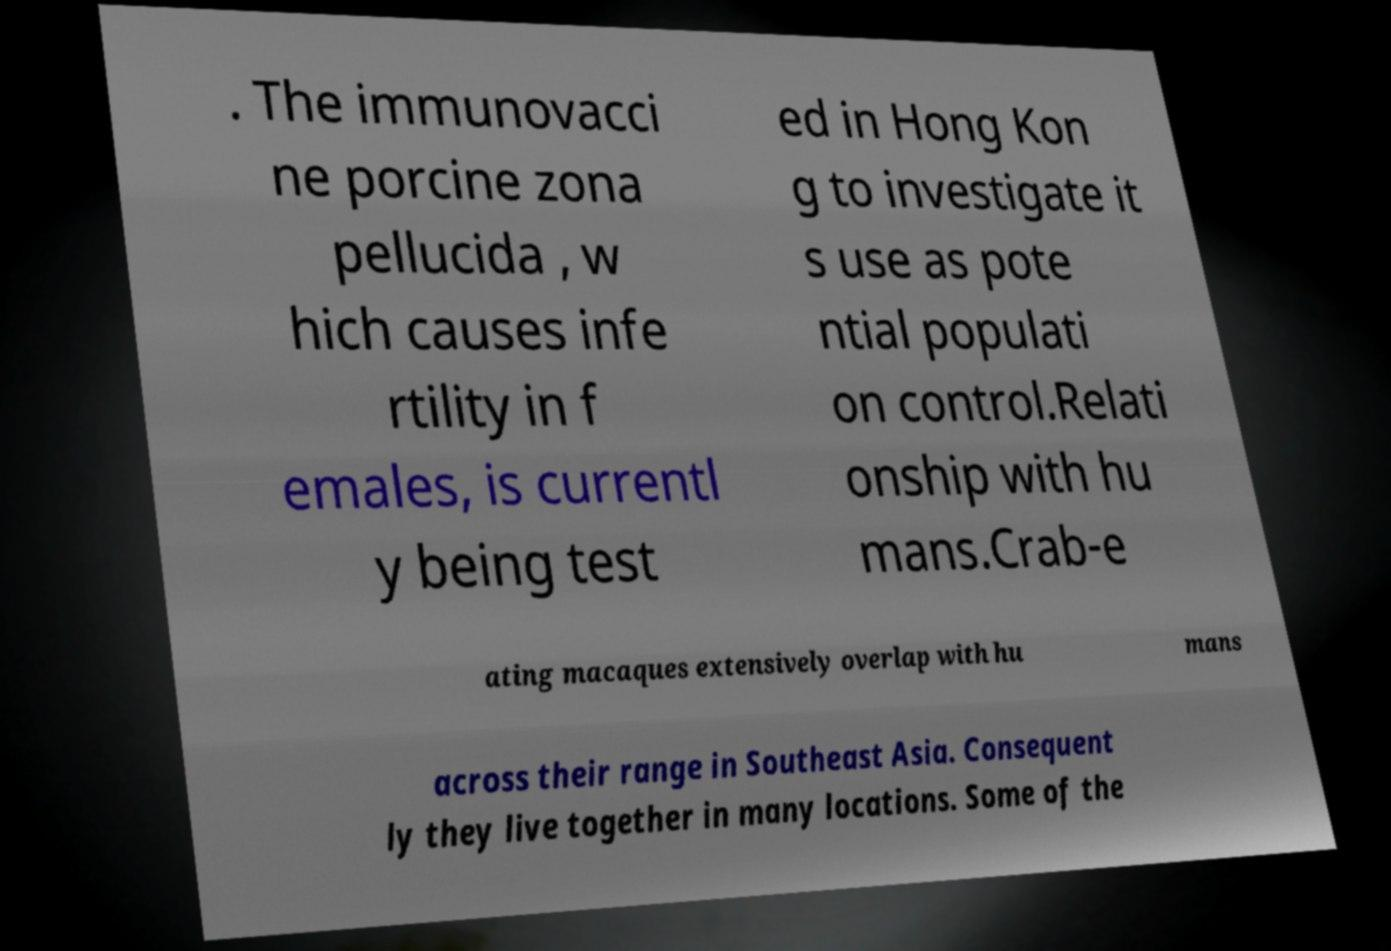I need the written content from this picture converted into text. Can you do that? . The immunovacci ne porcine zona pellucida , w hich causes infe rtility in f emales, is currentl y being test ed in Hong Kon g to investigate it s use as pote ntial populati on control.Relati onship with hu mans.Crab-e ating macaques extensively overlap with hu mans across their range in Southeast Asia. Consequent ly they live together in many locations. Some of the 